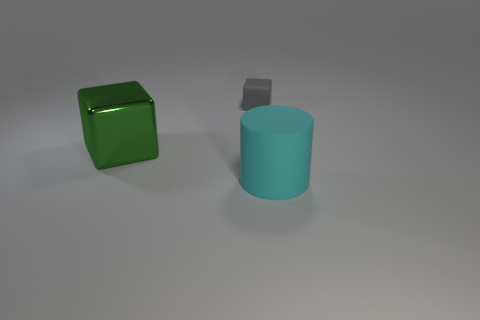Are there fewer gray cubes than matte objects?
Offer a terse response. Yes. Do the gray cube and the block that is in front of the rubber cube have the same size?
Provide a succinct answer. No. The object that is left of the matte thing that is to the left of the big rubber cylinder is what color?
Your answer should be very brief. Green. How many things are large things left of the small matte object or matte objects to the left of the big cyan rubber cylinder?
Offer a terse response. 2. Do the cyan cylinder and the gray block have the same size?
Offer a terse response. No. Is there anything else that has the same size as the gray matte thing?
Give a very brief answer. No. Is the shape of the big thing left of the cylinder the same as the matte object that is behind the big metal object?
Offer a very short reply. Yes. The cyan rubber object has what size?
Your answer should be compact. Large. What is the thing that is on the left side of the block behind the big thing left of the small gray thing made of?
Offer a very short reply. Metal. What number of other objects are there of the same color as the metal block?
Your response must be concise. 0. 